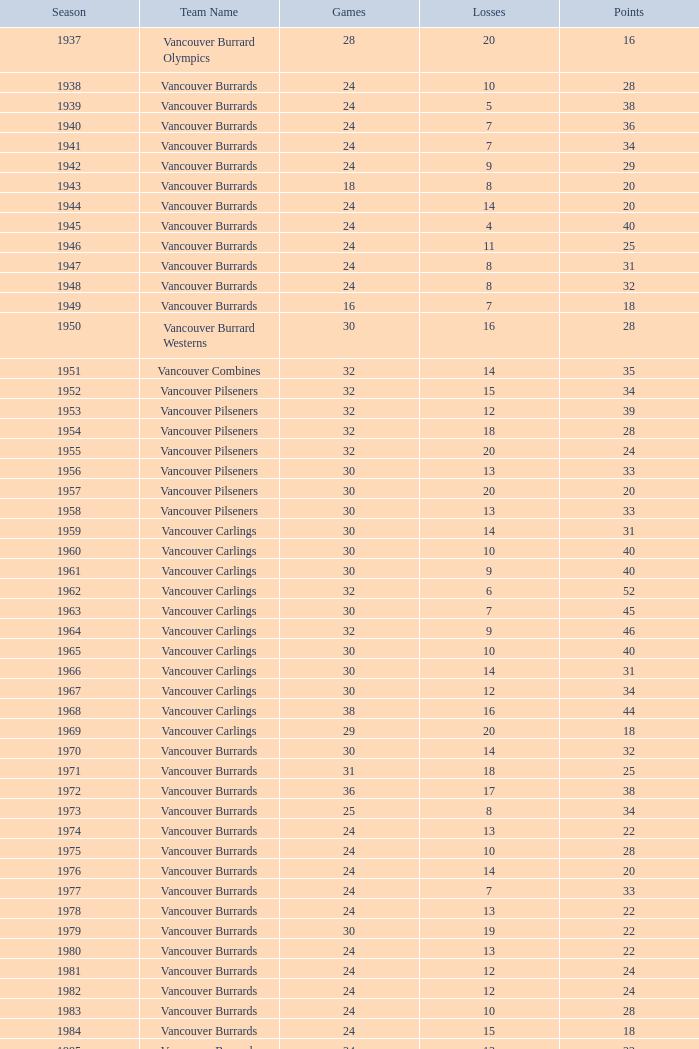What's the total losses for the vancouver burrards in the 1947 season with fewer than 24 games? 0.0. 